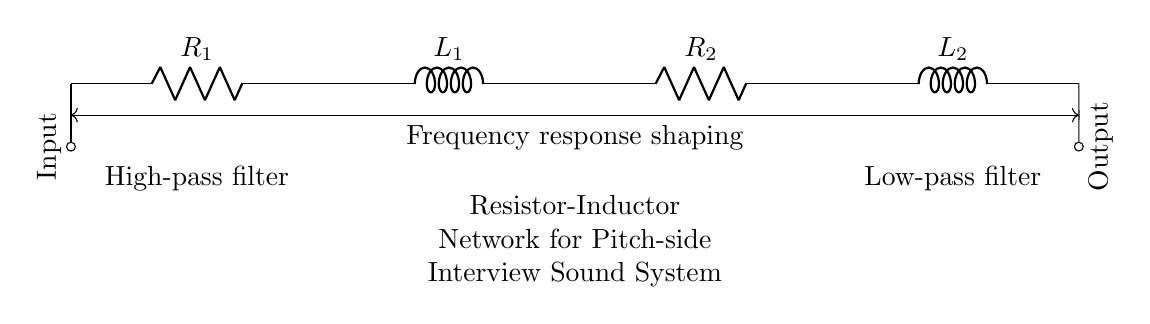What components are in this circuit? The circuit contains two resistors (R1, R2) and two inductors (L1, L2). These components are connected in a series configuration, which is indicated by the arrangement in the diagram.
Answer: Resistors and Inductors What is the function of R1 in this circuit? R1 acts as a high-pass filter, which allows high-frequency signals to pass through while attenuating lower frequencies. This is evident based on its placement at the input of the circuit.
Answer: High-pass filter What is the total number of components in this circuit? There are four components total: two resistors and two inductors. You can count each component in the schematic to arrive at this total.
Answer: Four What does the arrow indicate at the input and output? The arrow indicates the direction of signal flow. The input is where the audio signal begins, and the output is where the processed signal is taken from. This directionality helps to understand the signal processing sequence in the circuit.
Answer: Input and output direction What is the purpose of the frequency response shaping shown in the diagram? Frequency response shaping refers to the way in which this circuit modifies the amplitude of different frequencies of the signal. Given that R1 and L1 create a high-pass filter while R2 and L2 create a low-pass filter, it shapes the overall output signal for the desired audio quality during pitch-side interviews.
Answer: Modify audio signal frequencies What type of filter does R2 and L2 create? R2 and L2 together create a low-pass filter, which allows lower frequencies to pass while attenuating higher frequencies. This function is crucial for sound systems to balance out the overall tone of audio signals.
Answer: Low-pass filter What are the two types of filters represented in this circuit? The circuit features a high-pass filter (R1, L1) at the input and a low-pass filter (R2, L2) at the output, indicating a deliberate design choice to manage the frequency response of the audio signal.
Answer: High-pass and low-pass filters 